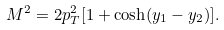Convert formula to latex. <formula><loc_0><loc_0><loc_500><loc_500>M ^ { 2 } = 2 p _ { T } ^ { 2 } [ 1 + \cosh ( y _ { 1 } - y _ { 2 } ) ] .</formula> 